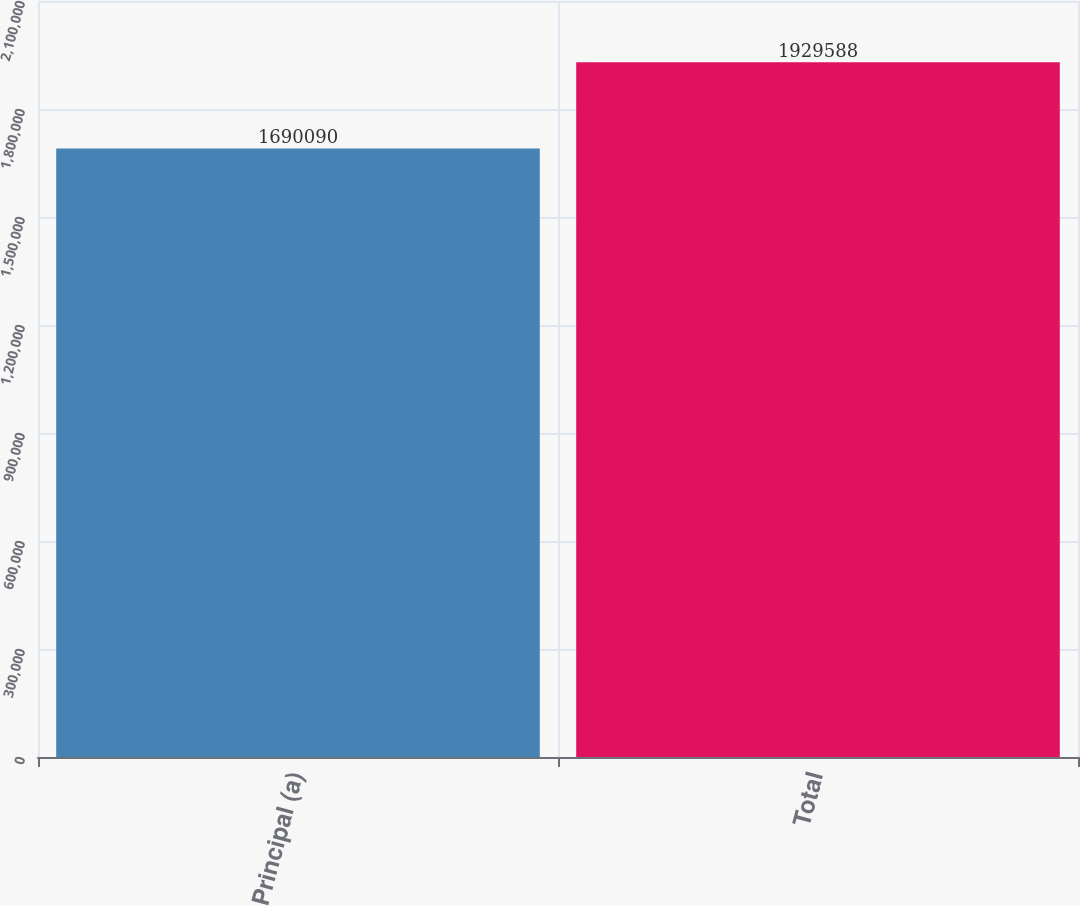Convert chart. <chart><loc_0><loc_0><loc_500><loc_500><bar_chart><fcel>Principal (a)<fcel>Total<nl><fcel>1.69009e+06<fcel>1.92959e+06<nl></chart> 